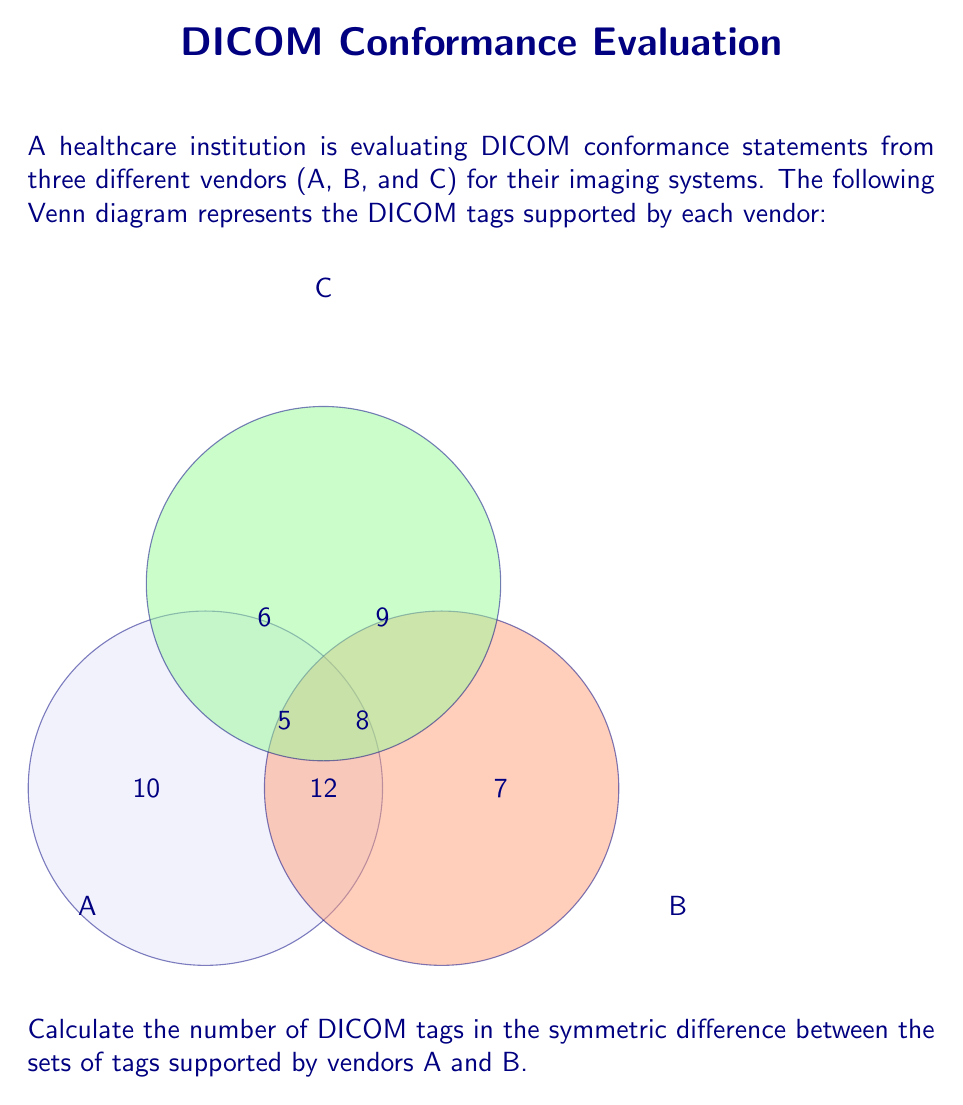Can you solve this math problem? To solve this problem, we need to understand the concept of symmetric difference and apply it to the given Venn diagram.

1. The symmetric difference between two sets A and B, denoted as $A \triangle B$, is defined as:
   $A \triangle B = (A \setminus B) \cup (B \setminus A)$

2. In other words, the symmetric difference includes elements that are in either A or B, but not in both.

3. From the Venn diagram:
   - Elements only in A: 10
   - Elements only in B: 7
   - Elements in both A and B (intersection): 12

4. The symmetric difference will include:
   - Elements only in A: 10
   - Elements only in B: 7

5. Calculate the total:
   $|A \triangle B| = 10 + 7 = 17$

Therefore, the symmetric difference between the sets of DICOM tags supported by vendors A and B contains 17 tags.
Answer: 17 